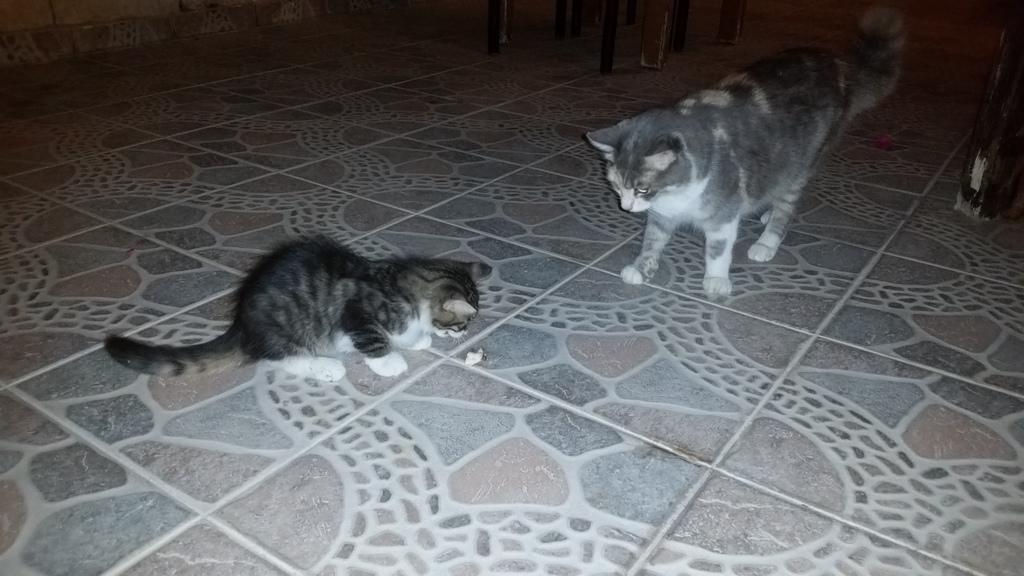Please provide a concise description of this image. In this image we can see the cats. In the background of the image there are some objects. At the bottom of the image there is the floor 